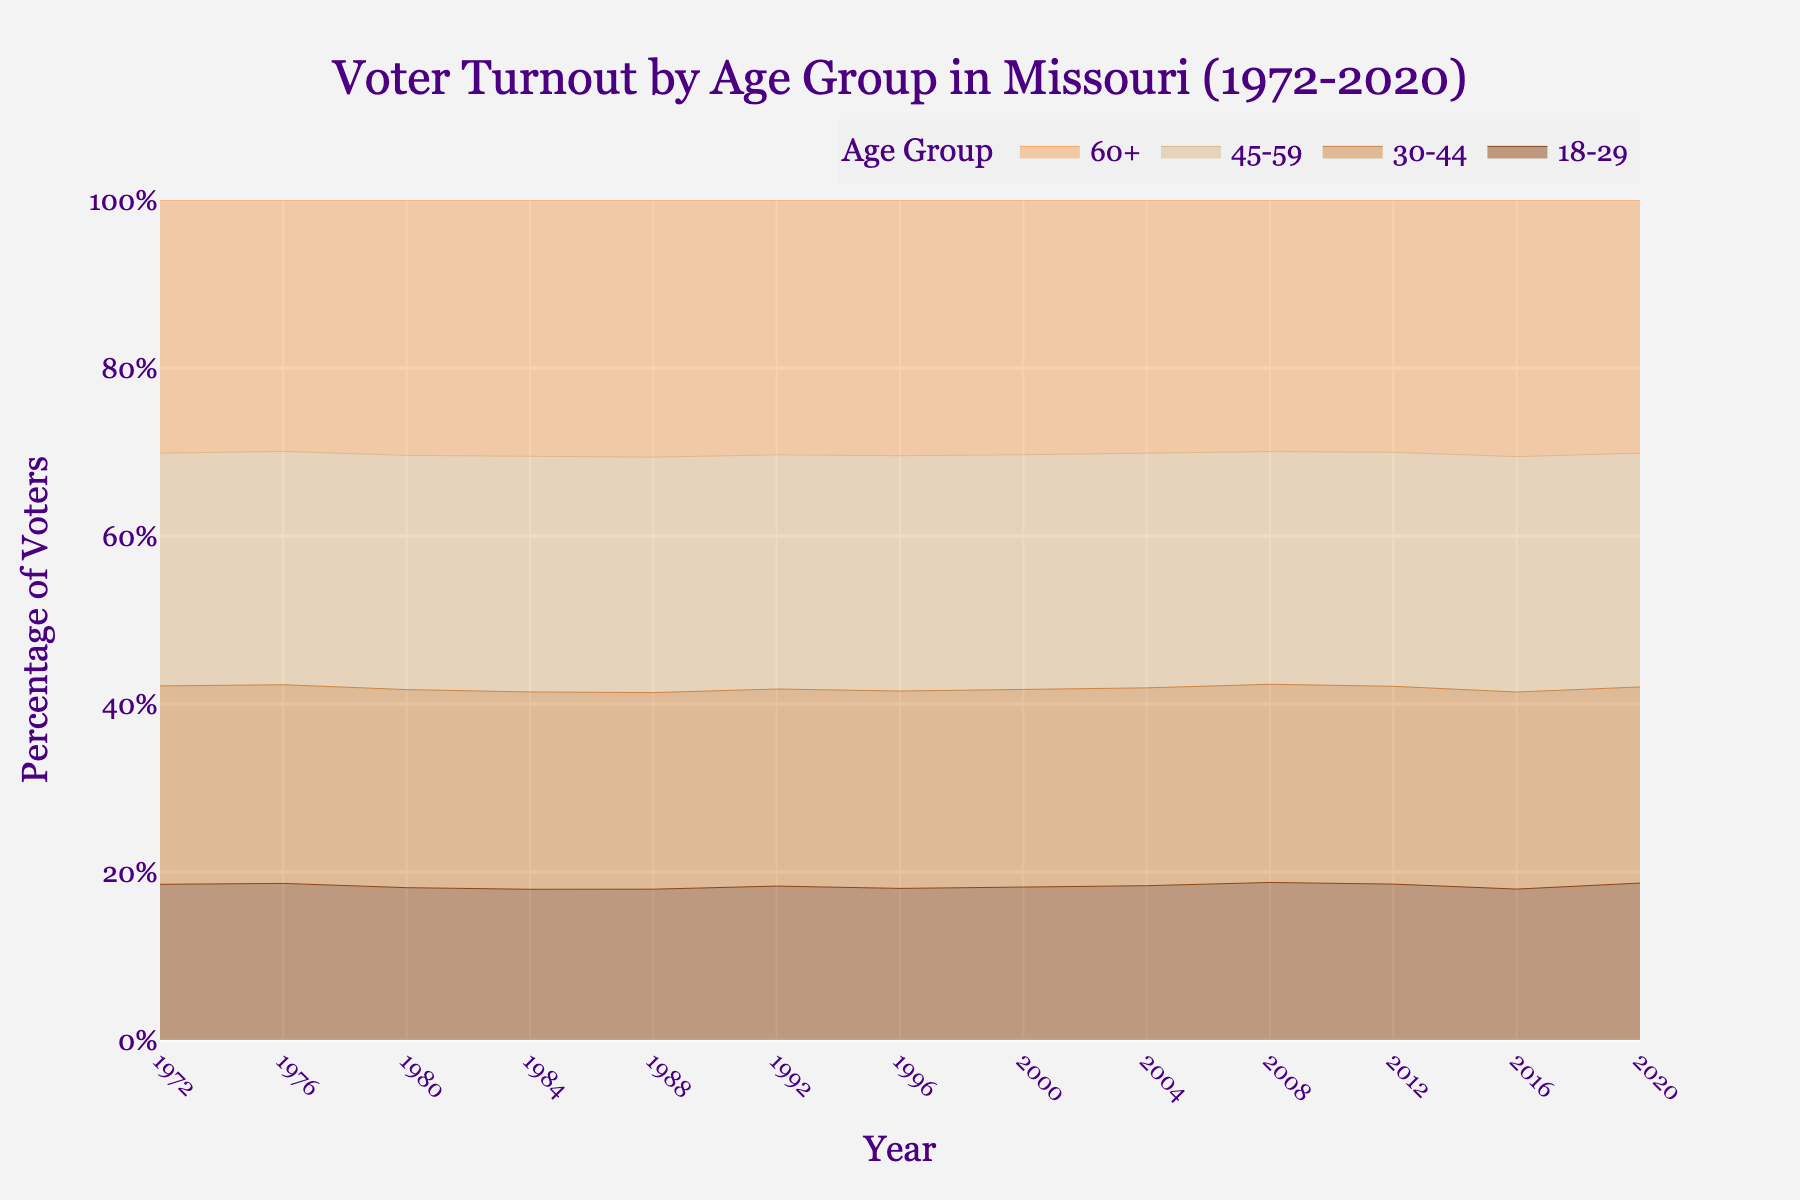What is the title of the plot? The plot title is prominently displayed at the top of the chart, which provides a clear description of what the chart is about.
Answer: Voter Turnout by Age Group in Missouri (1972-2020) Which age group has consistently the highest voter turnout? To answer this, observe the area on the chart corresponding to each age group over all the years. The 60+ age group consistently has the highest voter turnout as it consistently occupies the top portion of the stacked area.
Answer: 60+ Between which years does the 18-29 age group show the most significant increase in voter turnout? Look for the steepest upward slope in the area corresponding to the 18-29 age group. The period between 2004 and 2008 shows the most significant increase in voter turnout for this group.
Answer: 2004-2008 In what year did the 30-44 age group first cross 60% voter turnout? Identify the point where the area representing the 30-44 age group first reaches or surpasses the 60% mark along the vertical axis of the chart. This happened in the year 1972.
Answer: 1972 How does voter turnout in the 45-59 age group in 2020 compare to 1972? Observe the values for the 45-59 age group at the year markers 2020 and 1972 on the x-axis. Compare the two percentages. In 1972 it was 73.1% and in 2020, it was 75.1%.
Answer: Higher What is the general trend in voter turnout for the 18-29 age group from 1972 to 2020? Observe the overall change in the area representing the 18-29 age group from the beginning to the end of the timeline. The trend shows some fluctuations but is generally slightly increasing towards the end.
Answer: Slightly increasing Which age group experienced the smallest change in voter turnout from 1972 to 2020? Compare the initial and final values for each age group from the chart. The age group 60+ had a voter turnout of 79.5% in 1972 and 81.3% in 2020, showing the smallest change over the period.
Answer: 60+ During which period did the 30-44 age group show a noticeable decrease in voter turnout? Identify the period with a visible downward slope in the area corresponding to the 30-44 age group. The most noticeable decrease occurs between 2008 and 2016.
Answer: 2008-2016 What can be inferred about the voter turnout trends for all age groups over the 50-year span? Look at the general patterns and slopes of each age group's area over the 50 years. Older age groups (60+, 45-59) show higher turnout, while younger groups (18-29, 30-44) show more fluctuations. However, the overall trend is slightly upward for all groups.
Answer: Older groups have higher turnout; slight overall increase How did the voter turnout for the 45-59 age group change from 1988 to 1992? Observe the values for the 45-59 age group at the year markers 1988 and 1992 and calculate the difference. It went from 71.5% in 1988 to 73.8% in 1992, an increase of 2.3%.
Answer: Increased by 2.3% 